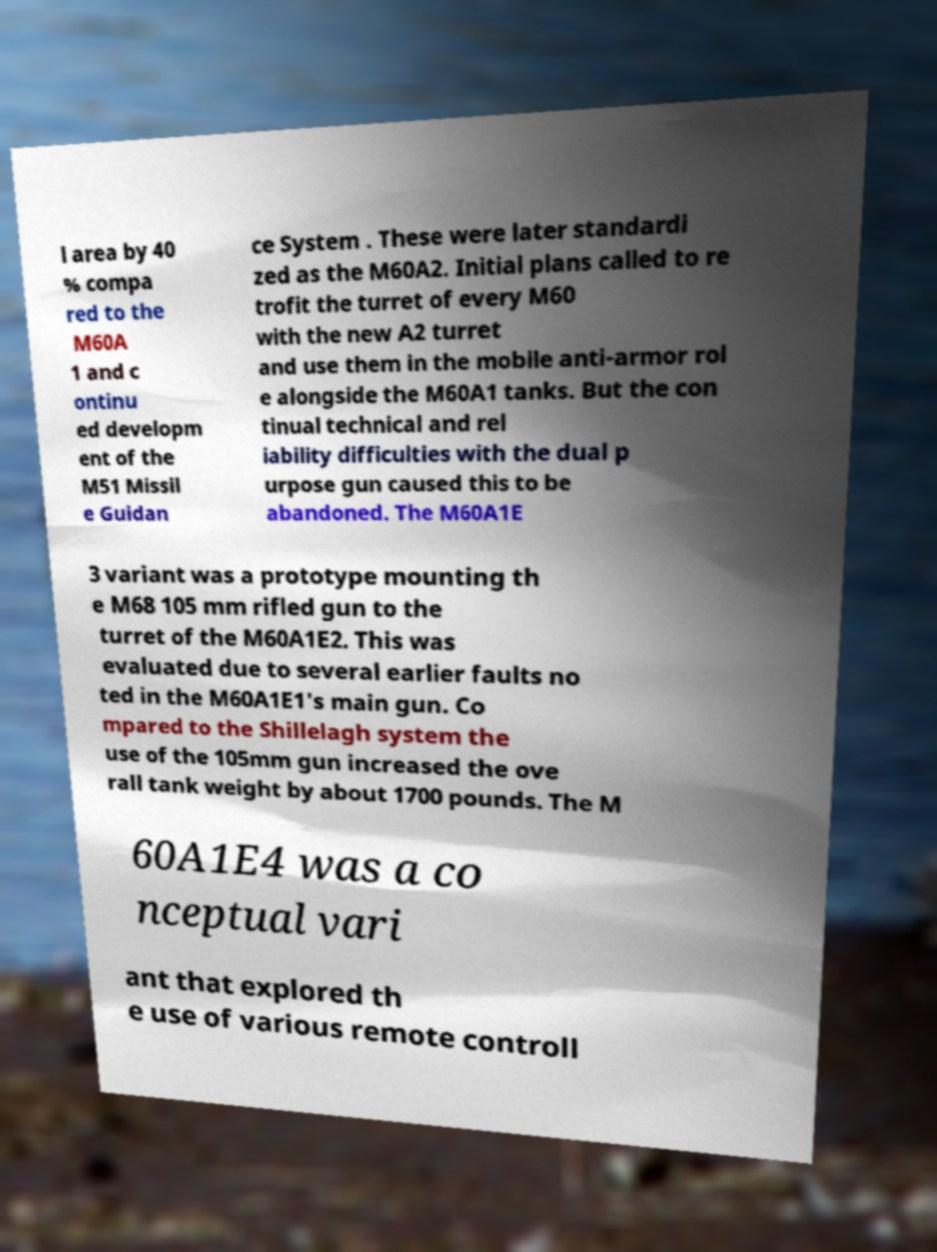For documentation purposes, I need the text within this image transcribed. Could you provide that? l area by 40 % compa red to the M60A 1 and c ontinu ed developm ent of the M51 Missil e Guidan ce System . These were later standardi zed as the M60A2. Initial plans called to re trofit the turret of every M60 with the new A2 turret and use them in the mobile anti-armor rol e alongside the M60A1 tanks. But the con tinual technical and rel iability difficulties with the dual p urpose gun caused this to be abandoned. The M60A1E 3 variant was a prototype mounting th e M68 105 mm rifled gun to the turret of the M60A1E2. This was evaluated due to several earlier faults no ted in the M60A1E1's main gun. Co mpared to the Shillelagh system the use of the 105mm gun increased the ove rall tank weight by about 1700 pounds. The M 60A1E4 was a co nceptual vari ant that explored th e use of various remote controll 